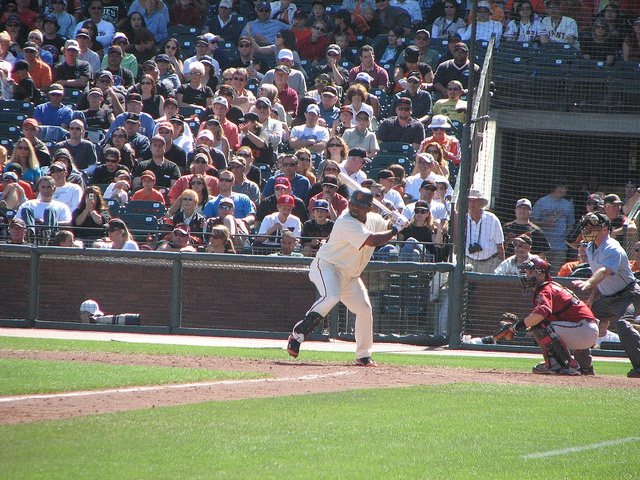Describe the objects in this image and their specific colors. I can see people in black, gray, navy, and white tones, people in black, tan, darkgray, lightgray, and gray tones, people in black, maroon, and gray tones, people in black, darkgray, gray, and white tones, and chair in black and purple tones in this image. 